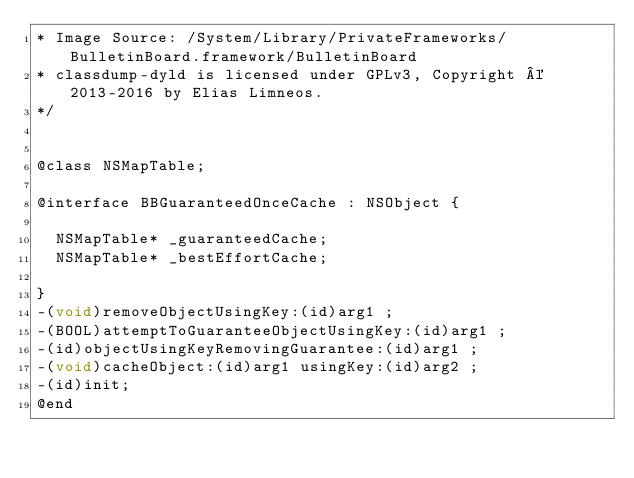<code> <loc_0><loc_0><loc_500><loc_500><_C_>* Image Source: /System/Library/PrivateFrameworks/BulletinBoard.framework/BulletinBoard
* classdump-dyld is licensed under GPLv3, Copyright © 2013-2016 by Elias Limneos.
*/


@class NSMapTable;

@interface BBGuaranteedOnceCache : NSObject {

	NSMapTable* _guaranteedCache;
	NSMapTable* _bestEffortCache;

}
-(void)removeObjectUsingKey:(id)arg1 ;
-(BOOL)attemptToGuaranteeObjectUsingKey:(id)arg1 ;
-(id)objectUsingKeyRemovingGuarantee:(id)arg1 ;
-(void)cacheObject:(id)arg1 usingKey:(id)arg2 ;
-(id)init;
@end

</code> 